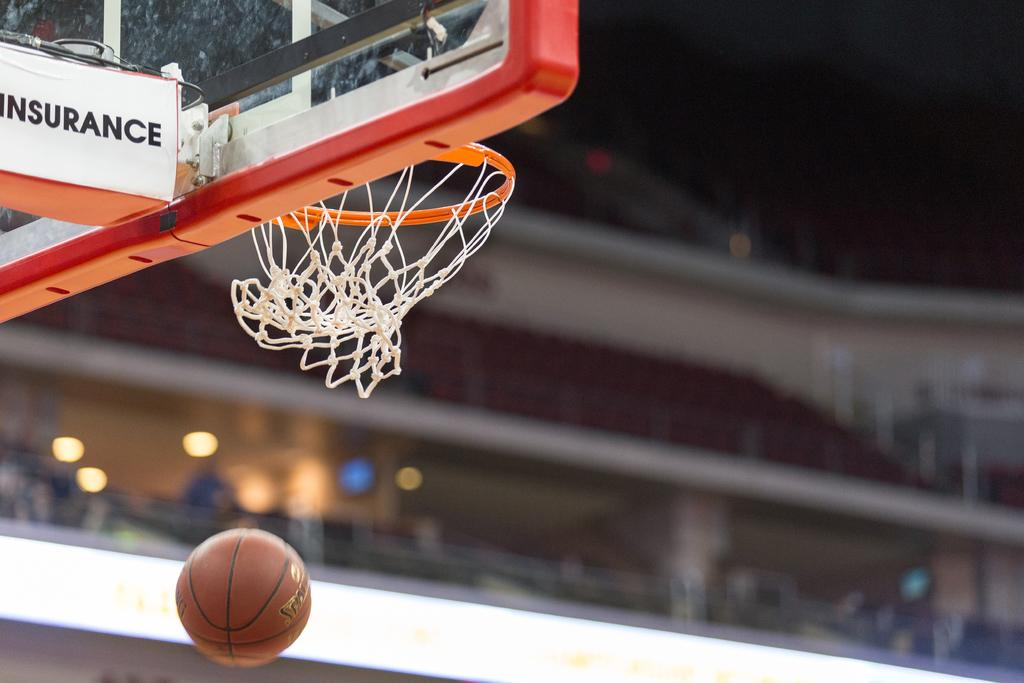What type of sports equipment is visible in the top left side of the image? There is a basketball hoop in the top left side of the image. What object is located at the bottom side of the image? There is a ball at the bottom side of the image. How many toes can be seen on the queen in the image? There is no queen or any toes visible in the image; it only features a basketball hoop and a ball. 